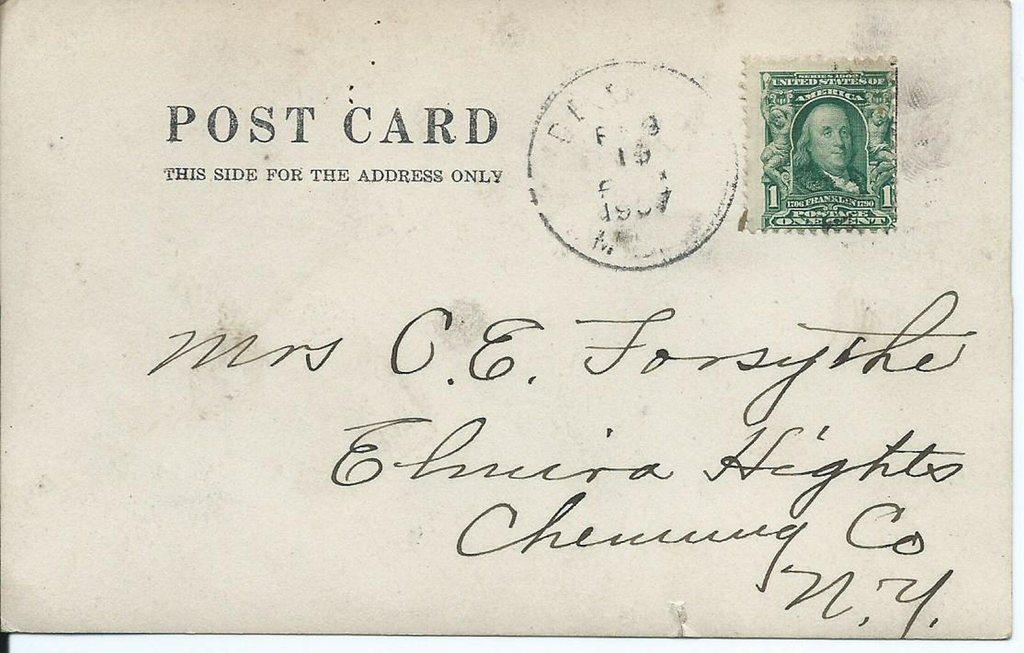<image>
Present a compact description of the photo's key features. A postcard with marking that says "This side for the address only". 